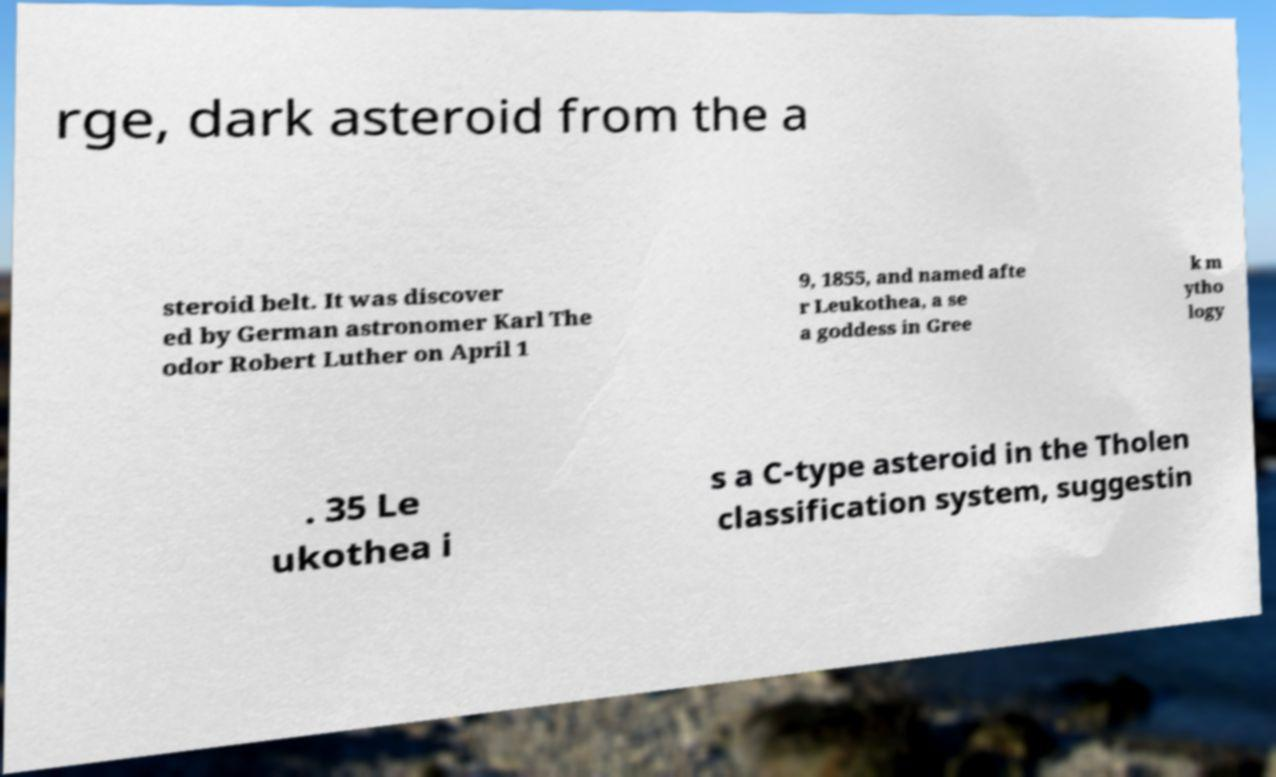For documentation purposes, I need the text within this image transcribed. Could you provide that? rge, dark asteroid from the a steroid belt. It was discover ed by German astronomer Karl The odor Robert Luther on April 1 9, 1855, and named afte r Leukothea, a se a goddess in Gree k m ytho logy . 35 Le ukothea i s a C-type asteroid in the Tholen classification system, suggestin 